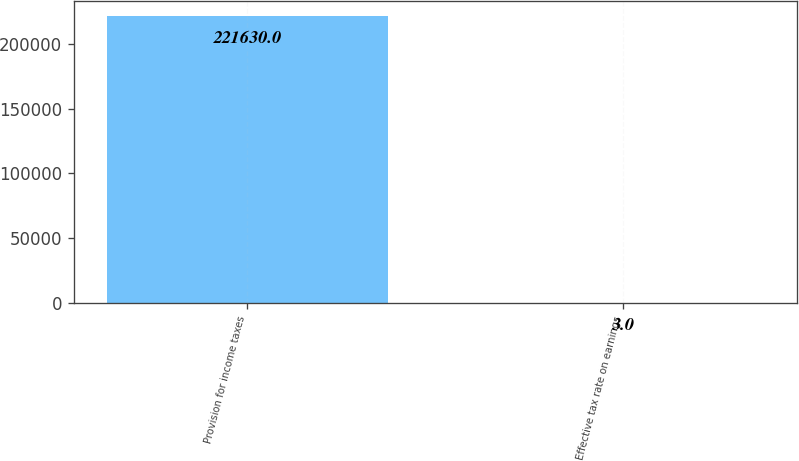Convert chart. <chart><loc_0><loc_0><loc_500><loc_500><bar_chart><fcel>Provision for income taxes<fcel>Effective tax rate on earnings<nl><fcel>221630<fcel>3<nl></chart> 